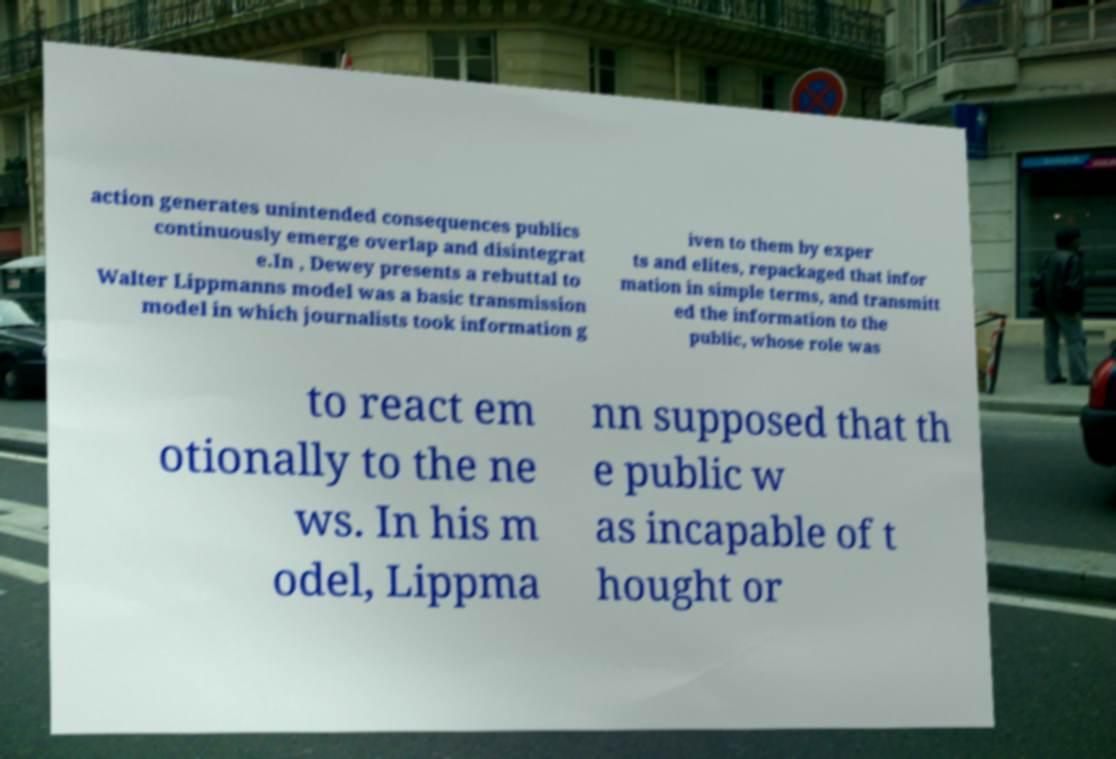I need the written content from this picture converted into text. Can you do that? action generates unintended consequences publics continuously emerge overlap and disintegrat e.In , Dewey presents a rebuttal to Walter Lippmanns model was a basic transmission model in which journalists took information g iven to them by exper ts and elites, repackaged that infor mation in simple terms, and transmitt ed the information to the public, whose role was to react em otionally to the ne ws. In his m odel, Lippma nn supposed that th e public w as incapable of t hought or 